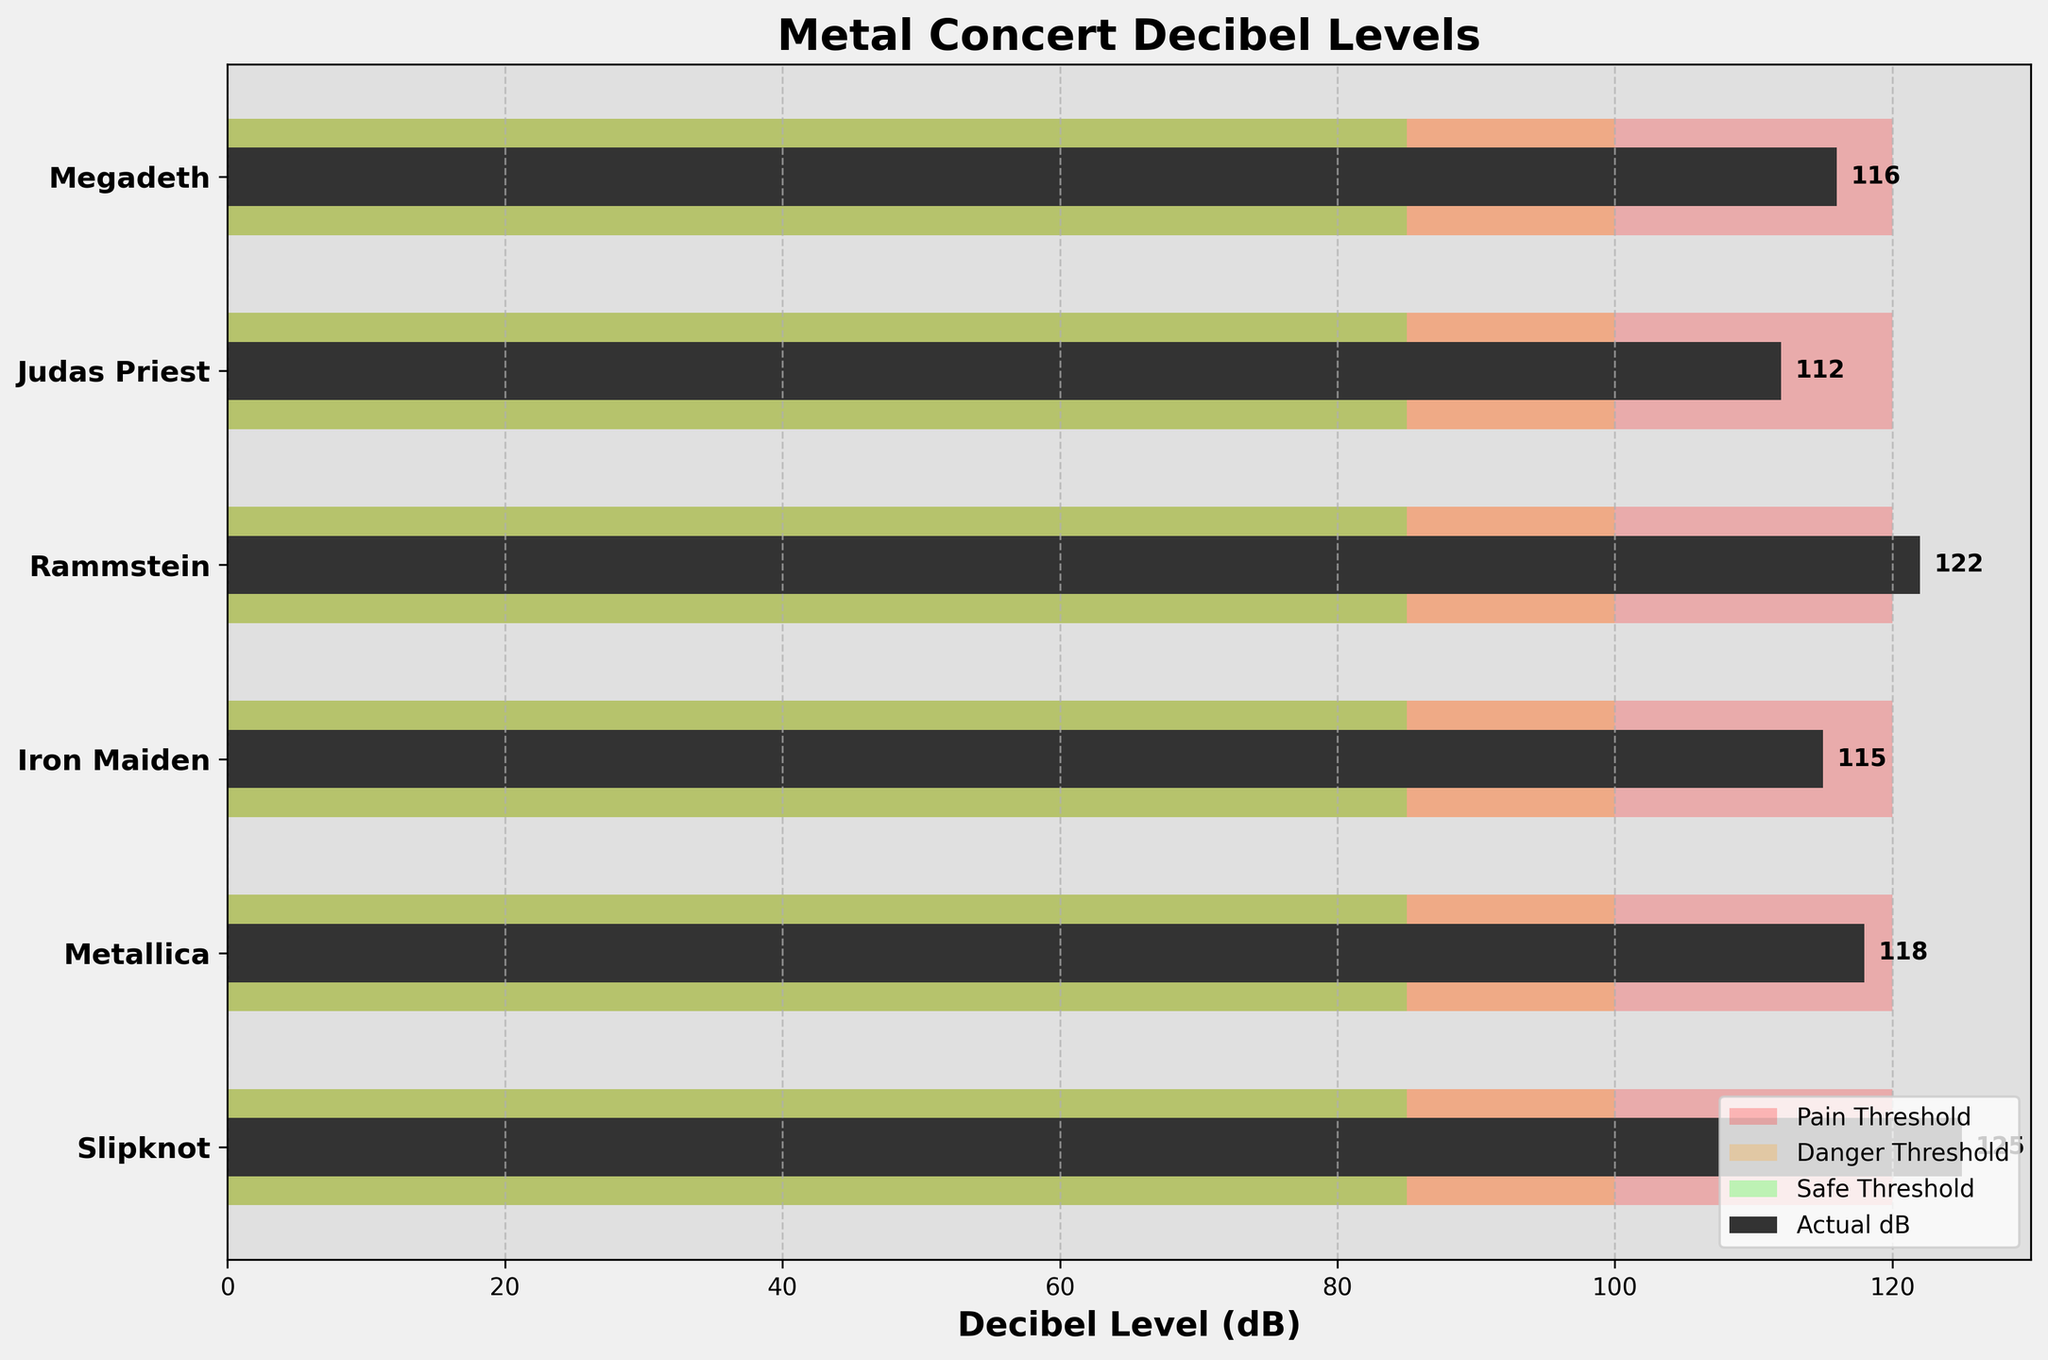What are the colors used for the safe, danger, and pain thresholds? The safe threshold is represented in green, the danger threshold in orange, and the pain threshold in red.
Answer: Green, Orange, Red What is the highest decibel level recorded, and which concert was it? The highest decibel level recorded is 125 dB at the Slipknot concert.
Answer: Slipknot, 125 dB How many concerts exceed the pain threshold? The pain threshold is 120 dB. Slipknot (125 dB) and Rammstein (122 dB) exceed this limit.
Answer: 2 concerts What is the difference in decibel level between the Slipknot and Metallica concerts? The decibel levels for Slipknot and Metallica are 125 dB and 118 dB, respectively. The difference is 125 - 118 = 7.
Answer: 7 dB Compare the actual dB levels of Judas Priest and Megadeth concerts. Which is higher and by how much? Judas Priest has an actual dB level of 112, and Megadeth has 116. Megadeth is higher by 116 - 112 = 4.
Answer: Megadeth, 4 dB Which concert has the lowest actual decibel level, and what is its value? Judas Priest concert has the lowest actual decibel level, which is 112 dB.
Answer: Judas Priest, 112 dB How many concerts are within the danger threshold (85-100 dB)? None of the concerts fall within the danger threshold range of 85-100 dB.
Answer: None What is the average actual decibel level across all the concerts? The actual levels are 125, 118, 115, 122, 112, 116. Summing these values gives 125 + 118 + 115 + 122 + 112 + 116 = 708. Dividing by the number of concerts (6) gives an average of 708 / 6 = 118.
Answer: 118 dB Which concert is just below the pain threshold, and what is its value? Rammstein concert is just below the pain threshold with a value of 122 dB, just under the 120 dB pain threshold.
Answer: Rammstein, 122 dB 